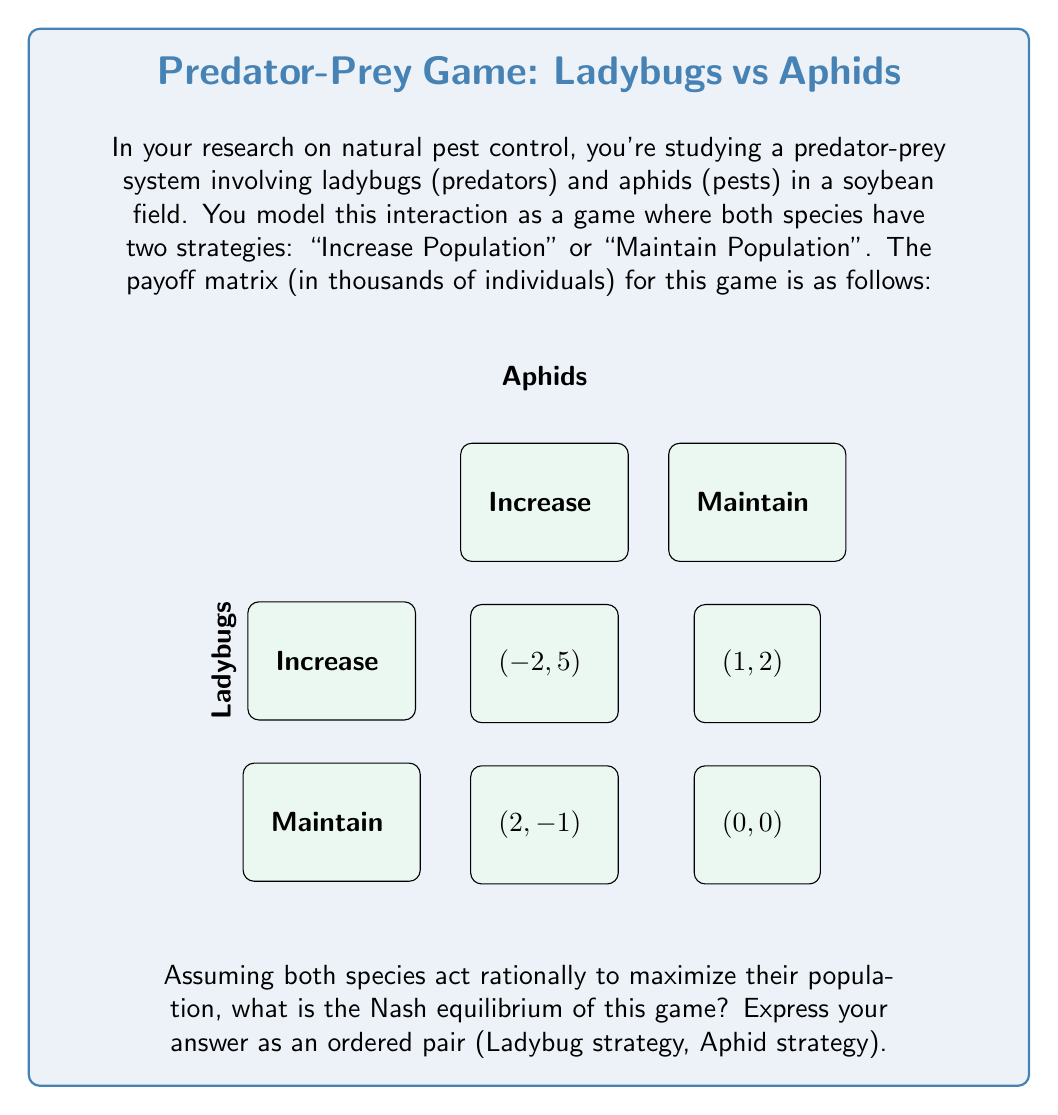Can you answer this question? To solve this problem, we need to analyze the game using the concept of Nash equilibrium from game theory. A Nash equilibrium is a set of strategies where neither player can unilaterally change their strategy to increase their payoff.

Let's approach this step-by-step:

1) First, let's identify the best responses for each player given the other's strategy:

   For Ladybugs:
   - If Aphids Increase: max(-2, 1) = 1 (Maintain)
   - If Aphids Maintain: max(2, 0) = 2 (Increase)

   For Aphids:
   - If Ladybugs Increase: max(5, -1) = 5 (Increase)
   - If Ladybugs Maintain: max(2, 0) = 2 (Increase)

2) Now, we can identify the Nash equilibrium by finding a cell where both players are playing their best response to the other's strategy.

3) Looking at the payoff matrix, we can see that when:
   - Ladybugs Maintain and Aphids Increase: Ladybugs are playing their best response (1 > -2), but Aphids could do better by still Increasing (5 > 2).
   - Ladybugs Increase and Aphids Increase: Both players are playing their best response. Ladybugs get 1 (which is better than -2 if they Maintained), and Aphids get 5 (which is their best outcome).

4) Therefore, the Nash equilibrium is (Increase, Increase).

This equilibrium represents a situation where both species are increasing their population, leading to an ongoing "arms race" in the ecosystem. This mirrors real-world observations in predator-prey dynamics, where populations often cycle as they respond to each other's changes.
Answer: (Increase, Increase) 